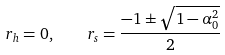Convert formula to latex. <formula><loc_0><loc_0><loc_500><loc_500>r _ { h } = 0 , \quad r _ { s } = \frac { - 1 \pm \sqrt { 1 - \alpha _ { 0 } ^ { 2 } } } { 2 }</formula> 